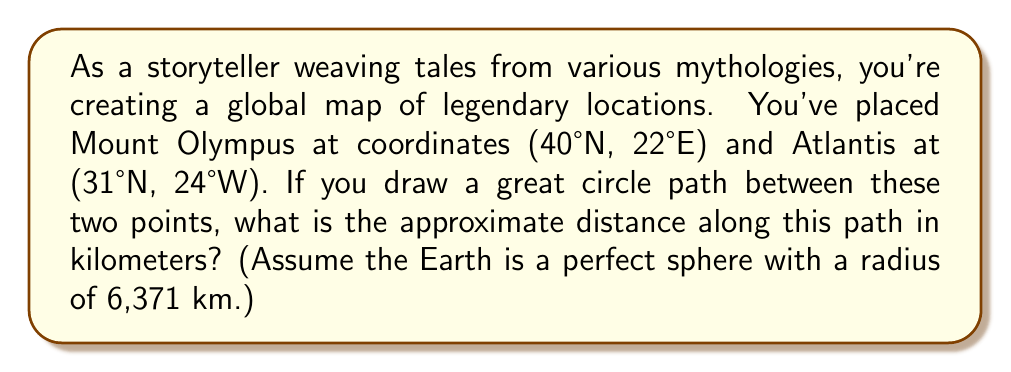Help me with this question. To solve this problem, we'll use the haversine formula, which calculates the great-circle distance between two points on a sphere given their latitudes and longitudes. Here's the step-by-step process:

1. Convert the latitudes and longitudes from degrees to radians:
   Mount Olympus: $\phi_1 = 40° \cdot \frac{\pi}{180} = 0.6981$ rad, $\lambda_1 = 22° \cdot \frac{\pi}{180} = 0.3840$ rad
   Atlantis: $\phi_2 = 31° \cdot \frac{\pi}{180} = 0.5411$ rad, $\lambda_2 = -24° \cdot \frac{\pi}{180} = -0.4189$ rad

2. Calculate the difference in longitude:
   $\Delta\lambda = \lambda_2 - \lambda_1 = -0.4189 - 0.3840 = -0.8029$ rad

3. Apply the haversine formula:
   $$a = \sin^2(\frac{\Delta\phi}{2}) + \cos(\phi_1) \cdot \cos(\phi_2) \cdot \sin^2(\frac{\Delta\lambda}{2})$$
   $$c = 2 \cdot \arctan2(\sqrt{a}, \sqrt{1-a})$$
   
   Where $\Delta\phi = \phi_2 - \phi_1 = 0.5411 - 0.6981 = -0.1570$ rad

4. Calculate $a$:
   $$a = \sin^2(-0.0785) + \cos(0.6981) \cdot \cos(0.5411) \cdot \sin^2(-0.4015)$$
   $$a = 0.1563$$

5. Calculate $c$:
   $$c = 2 \cdot \arctan2(\sqrt{0.1563}, \sqrt{1-0.1563}) = 0.8126$$

6. Calculate the distance $d$:
   $$d = R \cdot c$$
   Where $R$ is the radius of the Earth (6,371 km)
   $$d = 6371 \cdot 0.8126 = 5177.1 \text{ km}$$

7. Round to the nearest whole number:
   $$d \approx 5177 \text{ km}$$
Answer: The approximate distance along the great circle path between Mount Olympus and Atlantis is 5177 km. 